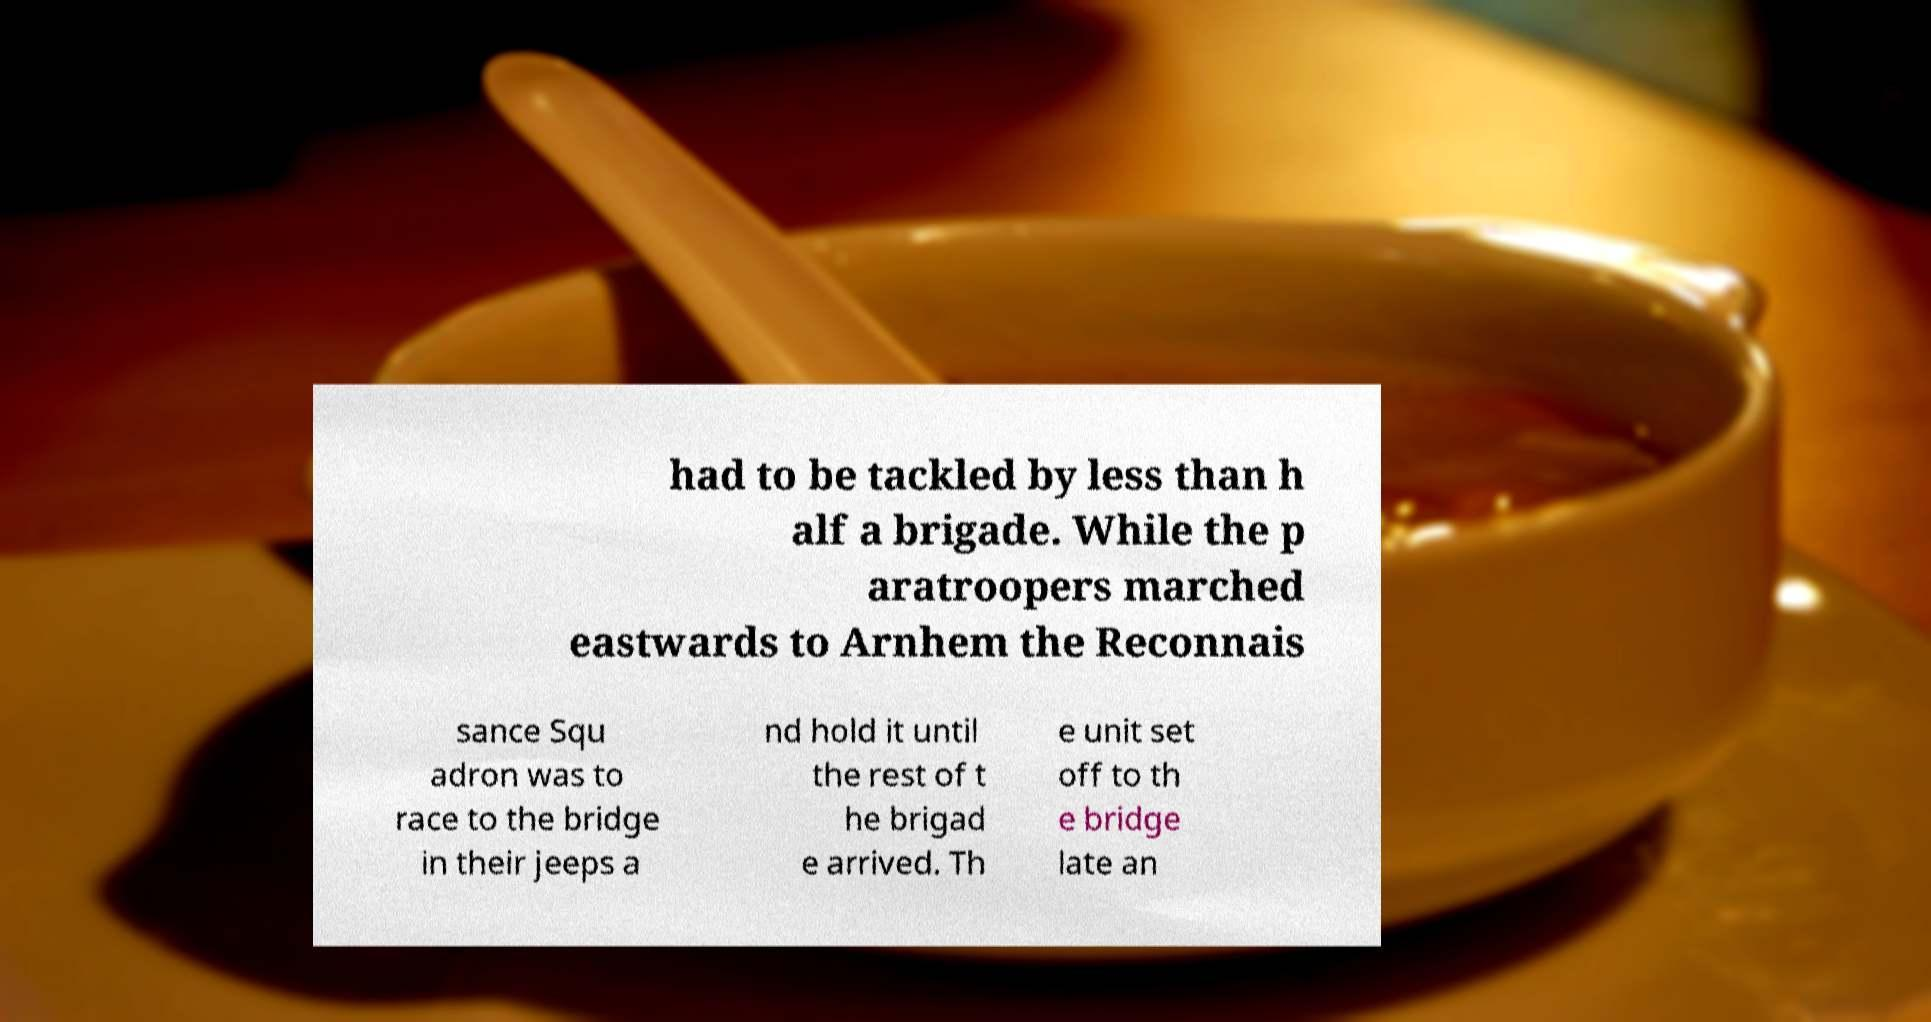Please read and relay the text visible in this image. What does it say? had to be tackled by less than h alf a brigade. While the p aratroopers marched eastwards to Arnhem the Reconnais sance Squ adron was to race to the bridge in their jeeps a nd hold it until the rest of t he brigad e arrived. Th e unit set off to th e bridge late an 